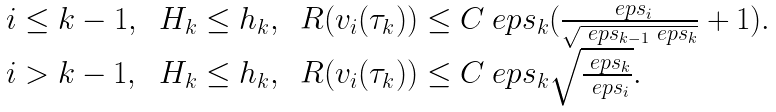<formula> <loc_0><loc_0><loc_500><loc_500>\begin{array} { l l l } i \leq k - 1 , \, & H _ { k } \leq h _ { k } , \, & R ( v _ { i } ( \tau _ { k } ) ) \leq C \ e p s _ { k } ( \frac { \ e p s _ { i } } { \sqrt { \ e p s _ { k - 1 } \ e p s _ { k } } } + 1 ) . \\ i > k - 1 , \, & H _ { k } \leq h _ { k } , \, & R ( v _ { i } ( \tau _ { k } ) ) \leq C \ e p s _ { k } \sqrt { \frac { \ e p s _ { k } } { \ e p s _ { i } } } . \\ \end{array}</formula> 